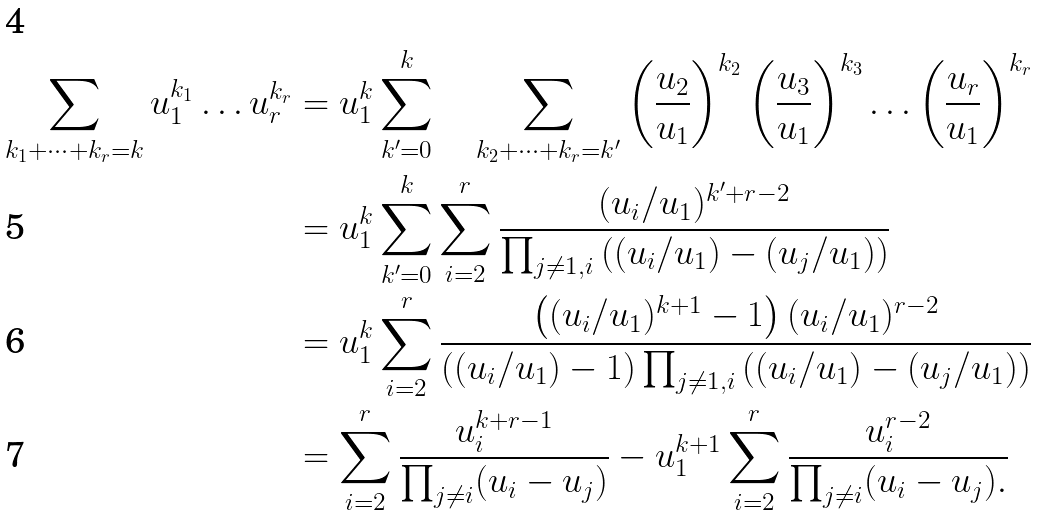<formula> <loc_0><loc_0><loc_500><loc_500>\sum _ { k _ { 1 } + \dots + k _ { r } = k } u _ { 1 } ^ { k _ { 1 } } \dots u _ { r } ^ { k _ { r } } & = u _ { 1 } ^ { k } \sum _ { k ^ { \prime } = 0 } ^ { k } \quad \sum _ { k _ { 2 } + \dots + k _ { r } = k ^ { \prime } } \left ( \frac { u _ { 2 } } { u _ { 1 } } \right ) ^ { k _ { 2 } } \left ( \frac { u _ { 3 } } { u _ { 1 } } \right ) ^ { k _ { 3 } } \dots \left ( \frac { u _ { r } } { u _ { 1 } } \right ) ^ { k _ { r } } \\ & = u _ { 1 } ^ { k } \sum _ { k ^ { \prime } = 0 } ^ { k } \sum _ { i = 2 } ^ { r } \frac { ( u _ { i } / u _ { 1 } ) ^ { k ^ { \prime } + r - 2 } } { \prod _ { j \ne 1 , i } \left ( ( u _ { i } / u _ { 1 } ) - ( u _ { j } / u _ { 1 } ) \right ) } \\ & = u _ { 1 } ^ { k } \sum _ { i = 2 } ^ { r } \frac { \left ( ( u _ { i } / u _ { 1 } ) ^ { k + 1 } - 1 \right ) ( u _ { i } / u _ { 1 } ) ^ { r - 2 } } { \left ( ( u _ { i } / u _ { 1 } ) - 1 \right ) \prod _ { j \ne 1 , i } \left ( ( u _ { i } / u _ { 1 } ) - ( u _ { j } / u _ { 1 } ) \right ) } \\ & = \sum _ { i = 2 } ^ { r } \frac { u _ { i } ^ { k + r - 1 } } { \prod _ { j \ne i } ( u _ { i } - u _ { j } ) } - u _ { 1 } ^ { k + 1 } \sum _ { i = 2 } ^ { r } \frac { u _ { i } ^ { r - 2 } } { \prod _ { j \ne i } ( u _ { i } - u _ { j } ) . }</formula> 